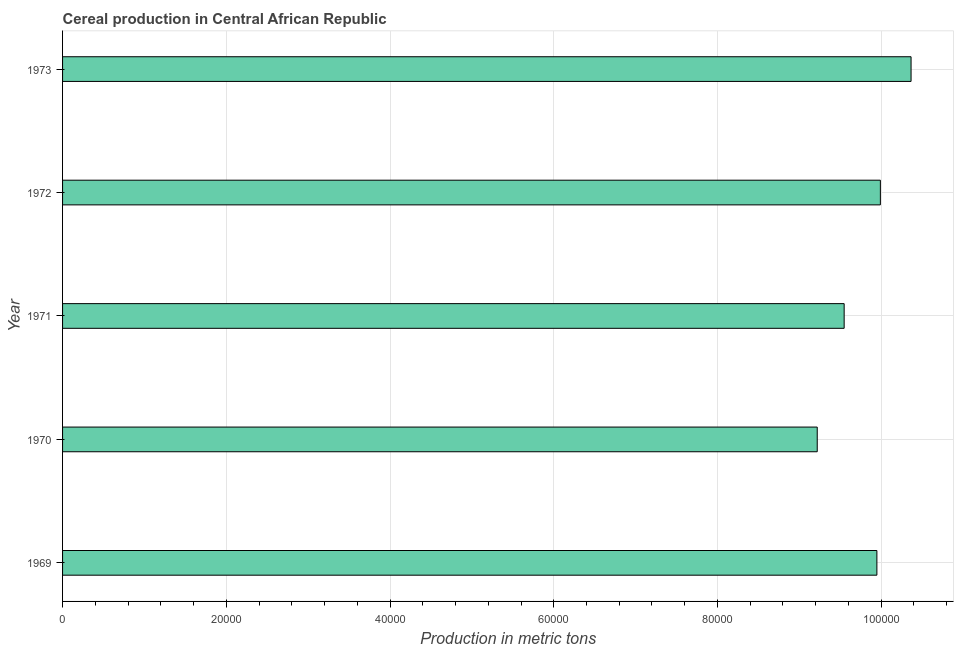Does the graph contain any zero values?
Provide a short and direct response. No. What is the title of the graph?
Your answer should be compact. Cereal production in Central African Republic. What is the label or title of the X-axis?
Make the answer very short. Production in metric tons. What is the cereal production in 1973?
Ensure brevity in your answer.  1.04e+05. Across all years, what is the maximum cereal production?
Make the answer very short. 1.04e+05. Across all years, what is the minimum cereal production?
Offer a terse response. 9.22e+04. In which year was the cereal production maximum?
Give a very brief answer. 1973. In which year was the cereal production minimum?
Your answer should be very brief. 1970. What is the sum of the cereal production?
Provide a succinct answer. 4.91e+05. What is the difference between the cereal production in 1971 and 1973?
Ensure brevity in your answer.  -8173. What is the average cereal production per year?
Offer a terse response. 9.81e+04. What is the median cereal production?
Provide a succinct answer. 9.95e+04. In how many years, is the cereal production greater than 28000 metric tons?
Your answer should be very brief. 5. What is the ratio of the cereal production in 1969 to that in 1973?
Offer a terse response. 0.96. Is the cereal production in 1969 less than that in 1970?
Your answer should be compact. No. What is the difference between the highest and the second highest cereal production?
Your response must be concise. 3750. What is the difference between the highest and the lowest cereal production?
Your answer should be compact. 1.15e+04. How many bars are there?
Offer a very short reply. 5. How many years are there in the graph?
Provide a succinct answer. 5. What is the difference between two consecutive major ticks on the X-axis?
Provide a short and direct response. 2.00e+04. Are the values on the major ticks of X-axis written in scientific E-notation?
Offer a terse response. No. What is the Production in metric tons in 1969?
Ensure brevity in your answer.  9.95e+04. What is the Production in metric tons in 1970?
Make the answer very short. 9.22e+04. What is the Production in metric tons in 1971?
Give a very brief answer. 9.55e+04. What is the Production in metric tons of 1972?
Your answer should be compact. 9.99e+04. What is the Production in metric tons in 1973?
Your answer should be very brief. 1.04e+05. What is the difference between the Production in metric tons in 1969 and 1970?
Your answer should be compact. 7288. What is the difference between the Production in metric tons in 1969 and 1971?
Provide a short and direct response. 3999. What is the difference between the Production in metric tons in 1969 and 1972?
Provide a succinct answer. -424. What is the difference between the Production in metric tons in 1969 and 1973?
Your answer should be compact. -4174. What is the difference between the Production in metric tons in 1970 and 1971?
Ensure brevity in your answer.  -3289. What is the difference between the Production in metric tons in 1970 and 1972?
Provide a short and direct response. -7712. What is the difference between the Production in metric tons in 1970 and 1973?
Your answer should be compact. -1.15e+04. What is the difference between the Production in metric tons in 1971 and 1972?
Your response must be concise. -4423. What is the difference between the Production in metric tons in 1971 and 1973?
Ensure brevity in your answer.  -8173. What is the difference between the Production in metric tons in 1972 and 1973?
Keep it short and to the point. -3750. What is the ratio of the Production in metric tons in 1969 to that in 1970?
Keep it short and to the point. 1.08. What is the ratio of the Production in metric tons in 1969 to that in 1971?
Your answer should be very brief. 1.04. What is the ratio of the Production in metric tons in 1969 to that in 1973?
Offer a terse response. 0.96. What is the ratio of the Production in metric tons in 1970 to that in 1971?
Ensure brevity in your answer.  0.97. What is the ratio of the Production in metric tons in 1970 to that in 1972?
Offer a very short reply. 0.92. What is the ratio of the Production in metric tons in 1970 to that in 1973?
Offer a terse response. 0.89. What is the ratio of the Production in metric tons in 1971 to that in 1972?
Provide a succinct answer. 0.96. What is the ratio of the Production in metric tons in 1971 to that in 1973?
Provide a short and direct response. 0.92. 